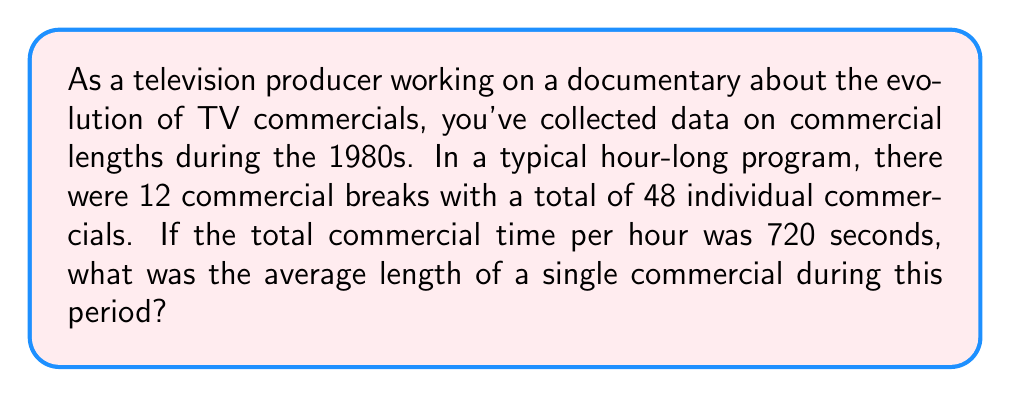Teach me how to tackle this problem. Let's approach this step-by-step:

1) First, we need to identify the key information:
   - Total commercial time per hour: 720 seconds
   - Number of individual commercials: 48

2) To find the average length of a single commercial, we need to divide the total commercial time by the number of commercials:

   $$\text{Average Length} = \frac{\text{Total Commercial Time}}{\text{Number of Commercials}}$$

3) Substituting our values:

   $$\text{Average Length} = \frac{720 \text{ seconds}}{48}$$

4) Performing the division:

   $$\text{Average Length} = 15 \text{ seconds}$$

Thus, the average length of a single commercial during this period was 15 seconds.
Answer: 15 seconds 